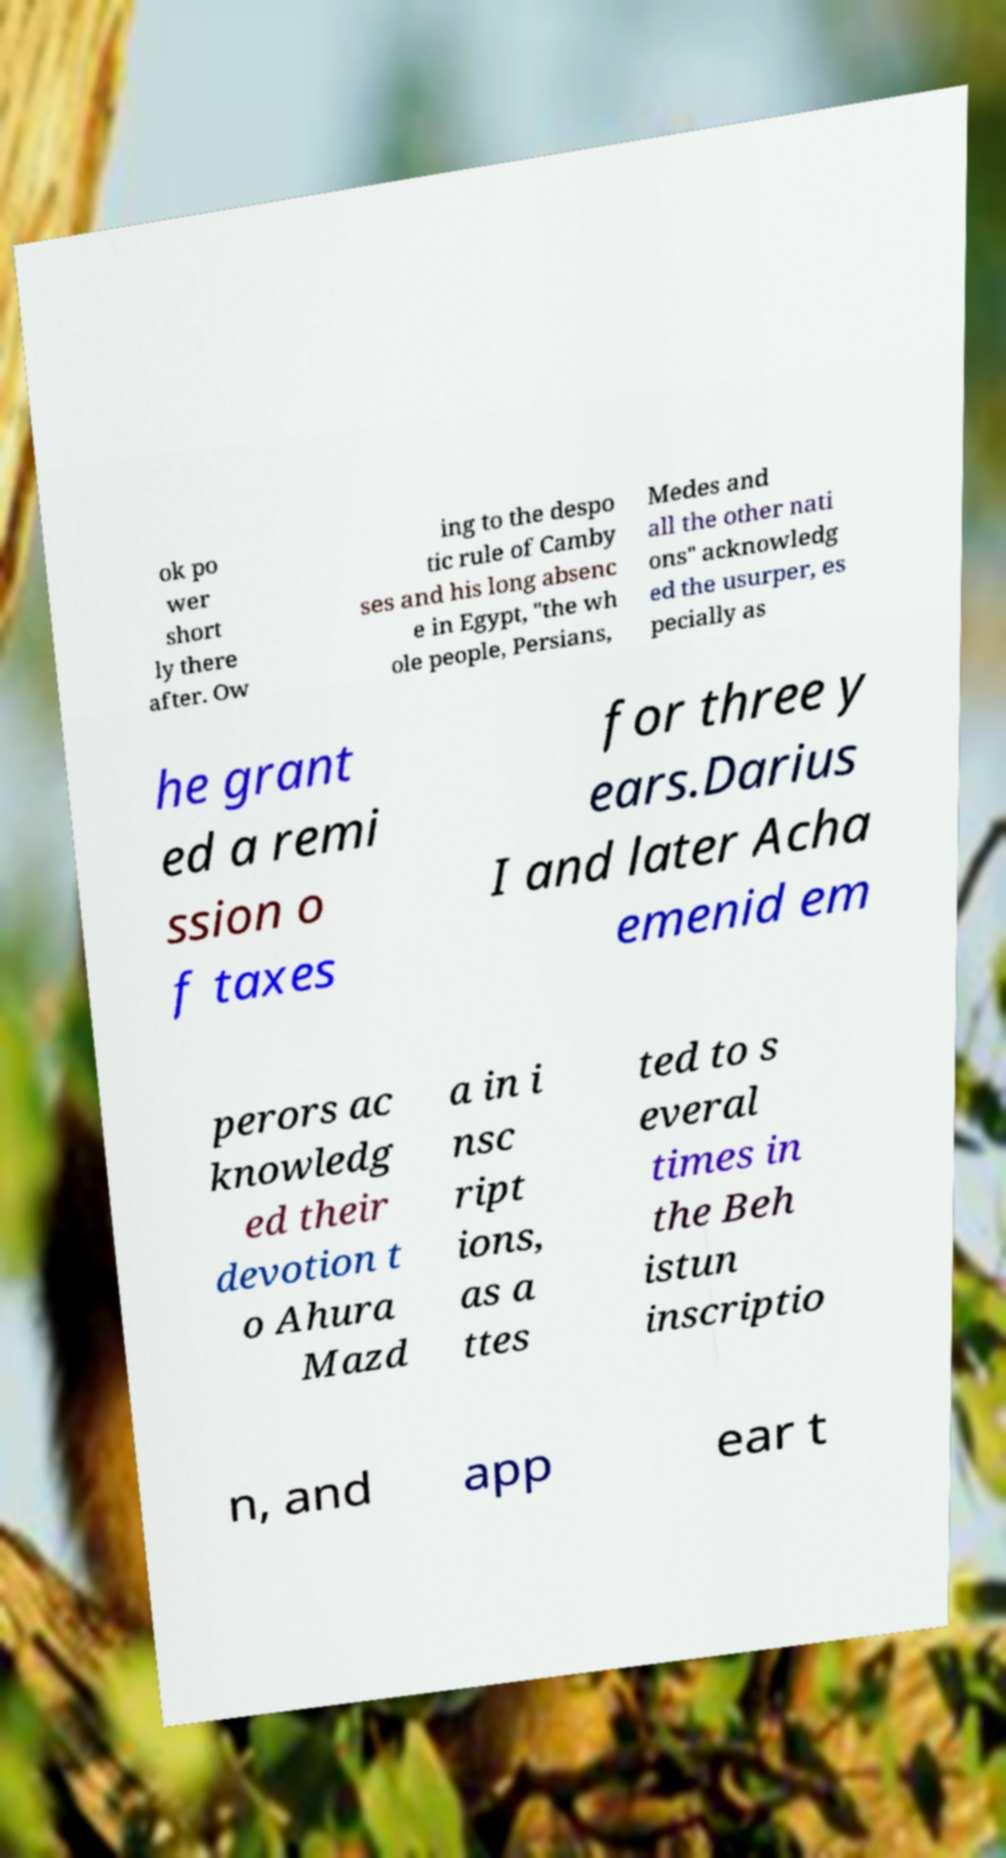There's text embedded in this image that I need extracted. Can you transcribe it verbatim? ok po wer short ly there after. Ow ing to the despo tic rule of Camby ses and his long absenc e in Egypt, "the wh ole people, Persians, Medes and all the other nati ons" acknowledg ed the usurper, es pecially as he grant ed a remi ssion o f taxes for three y ears.Darius I and later Acha emenid em perors ac knowledg ed their devotion t o Ahura Mazd a in i nsc ript ions, as a ttes ted to s everal times in the Beh istun inscriptio n, and app ear t 